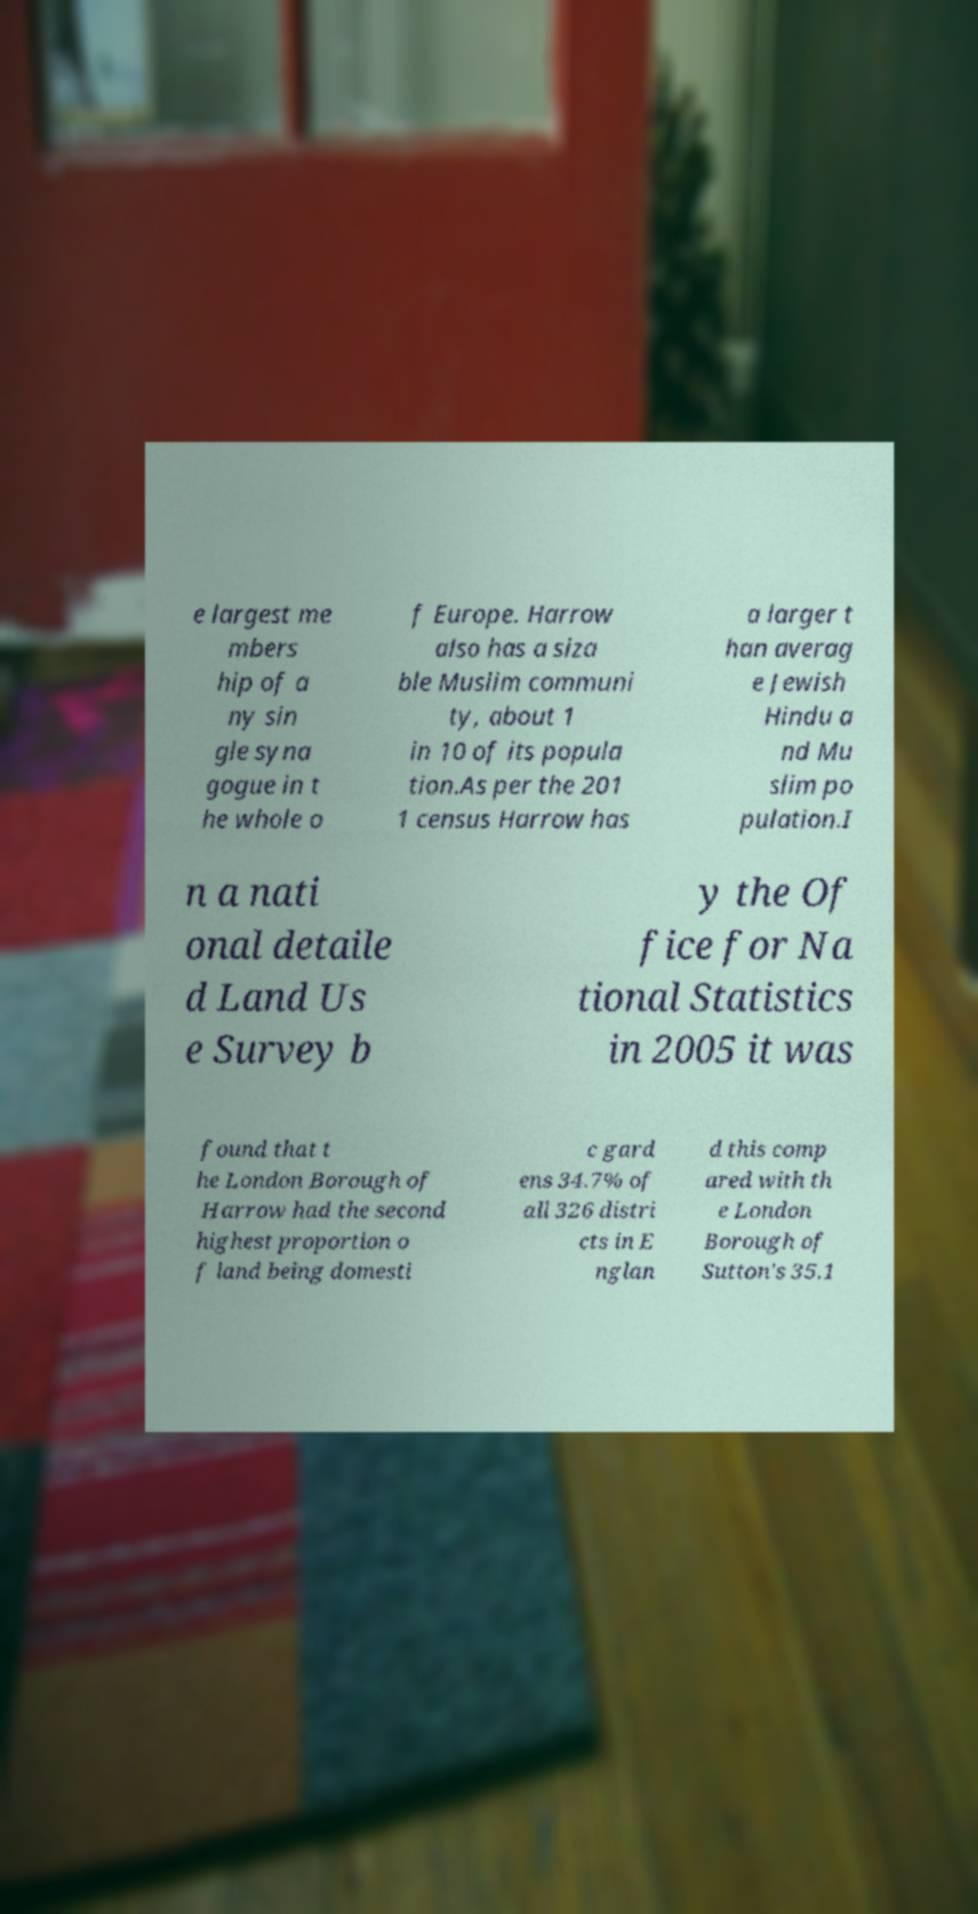I need the written content from this picture converted into text. Can you do that? e largest me mbers hip of a ny sin gle syna gogue in t he whole o f Europe. Harrow also has a siza ble Muslim communi ty, about 1 in 10 of its popula tion.As per the 201 1 census Harrow has a larger t han averag e Jewish Hindu a nd Mu slim po pulation.I n a nati onal detaile d Land Us e Survey b y the Of fice for Na tional Statistics in 2005 it was found that t he London Borough of Harrow had the second highest proportion o f land being domesti c gard ens 34.7% of all 326 distri cts in E nglan d this comp ared with th e London Borough of Sutton's 35.1 